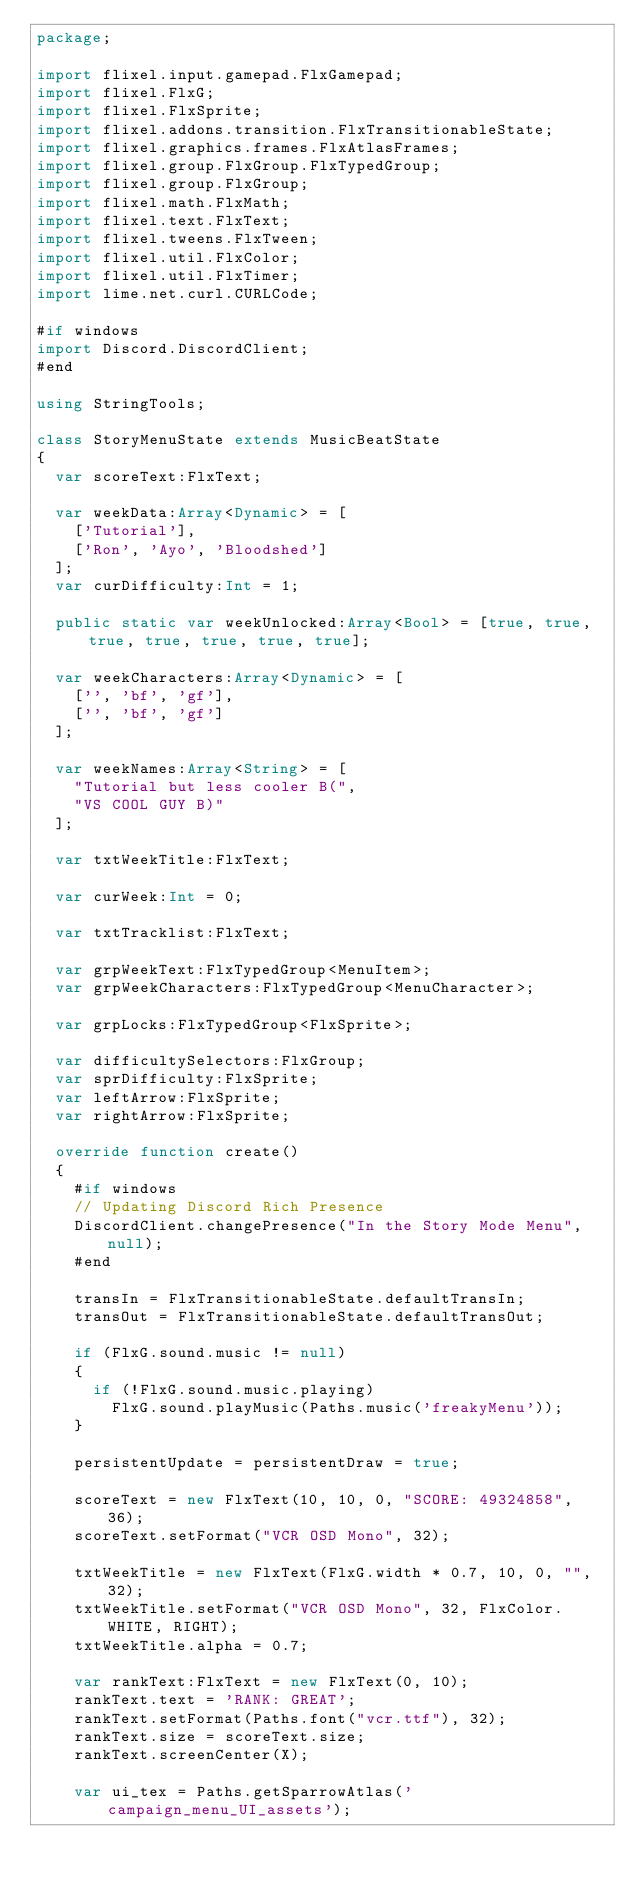Convert code to text. <code><loc_0><loc_0><loc_500><loc_500><_Haxe_>package;

import flixel.input.gamepad.FlxGamepad;
import flixel.FlxG;
import flixel.FlxSprite;
import flixel.addons.transition.FlxTransitionableState;
import flixel.graphics.frames.FlxAtlasFrames;
import flixel.group.FlxGroup.FlxTypedGroup;
import flixel.group.FlxGroup;
import flixel.math.FlxMath;
import flixel.text.FlxText;
import flixel.tweens.FlxTween;
import flixel.util.FlxColor;
import flixel.util.FlxTimer;
import lime.net.curl.CURLCode;

#if windows
import Discord.DiscordClient;
#end

using StringTools;

class StoryMenuState extends MusicBeatState
{
	var scoreText:FlxText;

	var weekData:Array<Dynamic> = [
		['Tutorial'],
		['Ron', 'Ayo', 'Bloodshed']
	];
	var curDifficulty:Int = 1;

	public static var weekUnlocked:Array<Bool> = [true, true, true, true, true, true, true];

	var weekCharacters:Array<Dynamic> = [
		['', 'bf', 'gf'],
		['', 'bf', 'gf']
	];

	var weekNames:Array<String> = [
		"Tutorial but less cooler B(",
		"VS COOL GUY B)"
	];

	var txtWeekTitle:FlxText;

	var curWeek:Int = 0;

	var txtTracklist:FlxText;

	var grpWeekText:FlxTypedGroup<MenuItem>;
	var grpWeekCharacters:FlxTypedGroup<MenuCharacter>;

	var grpLocks:FlxTypedGroup<FlxSprite>;

	var difficultySelectors:FlxGroup;
	var sprDifficulty:FlxSprite;
	var leftArrow:FlxSprite;
	var rightArrow:FlxSprite;

	override function create()
	{
		#if windows
		// Updating Discord Rich Presence
		DiscordClient.changePresence("In the Story Mode Menu", null);
		#end

		transIn = FlxTransitionableState.defaultTransIn;
		transOut = FlxTransitionableState.defaultTransOut;

		if (FlxG.sound.music != null)
		{
			if (!FlxG.sound.music.playing)
				FlxG.sound.playMusic(Paths.music('freakyMenu'));
		}

		persistentUpdate = persistentDraw = true;

		scoreText = new FlxText(10, 10, 0, "SCORE: 49324858", 36);
		scoreText.setFormat("VCR OSD Mono", 32);

		txtWeekTitle = new FlxText(FlxG.width * 0.7, 10, 0, "", 32);
		txtWeekTitle.setFormat("VCR OSD Mono", 32, FlxColor.WHITE, RIGHT);
		txtWeekTitle.alpha = 0.7;

		var rankText:FlxText = new FlxText(0, 10);
		rankText.text = 'RANK: GREAT';
		rankText.setFormat(Paths.font("vcr.ttf"), 32);
		rankText.size = scoreText.size;
		rankText.screenCenter(X);

		var ui_tex = Paths.getSparrowAtlas('campaign_menu_UI_assets');</code> 